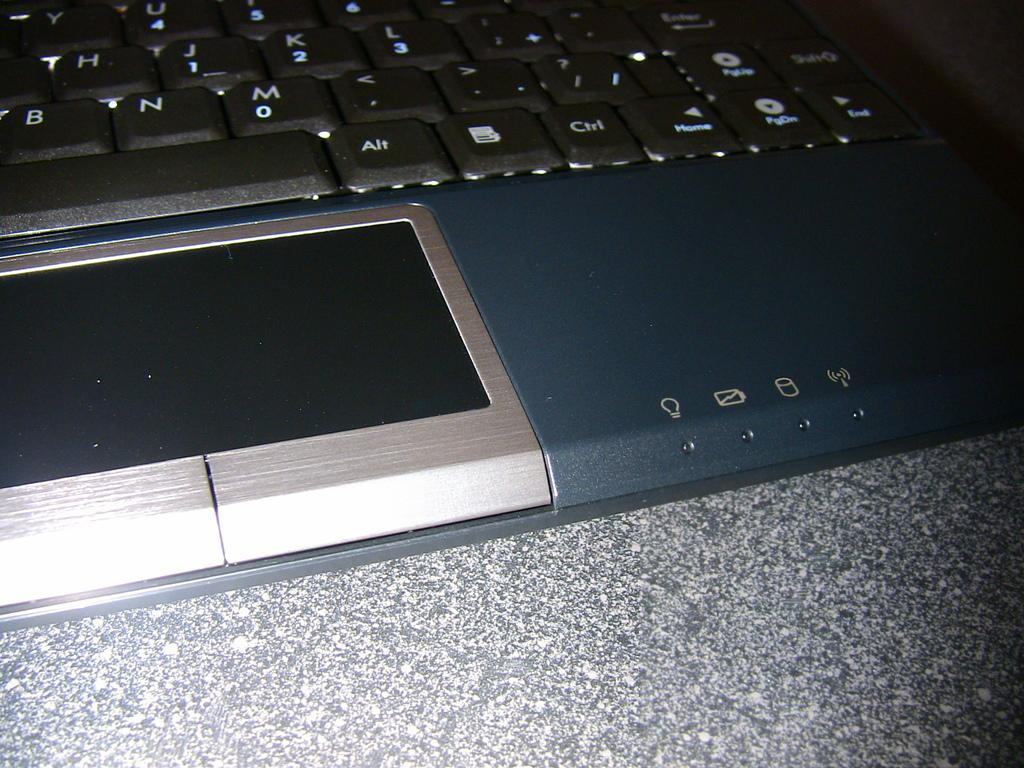<image>
Relay a brief, clear account of the picture shown. Alt Ctrl keys are highlighted on this laptop keyboard. 